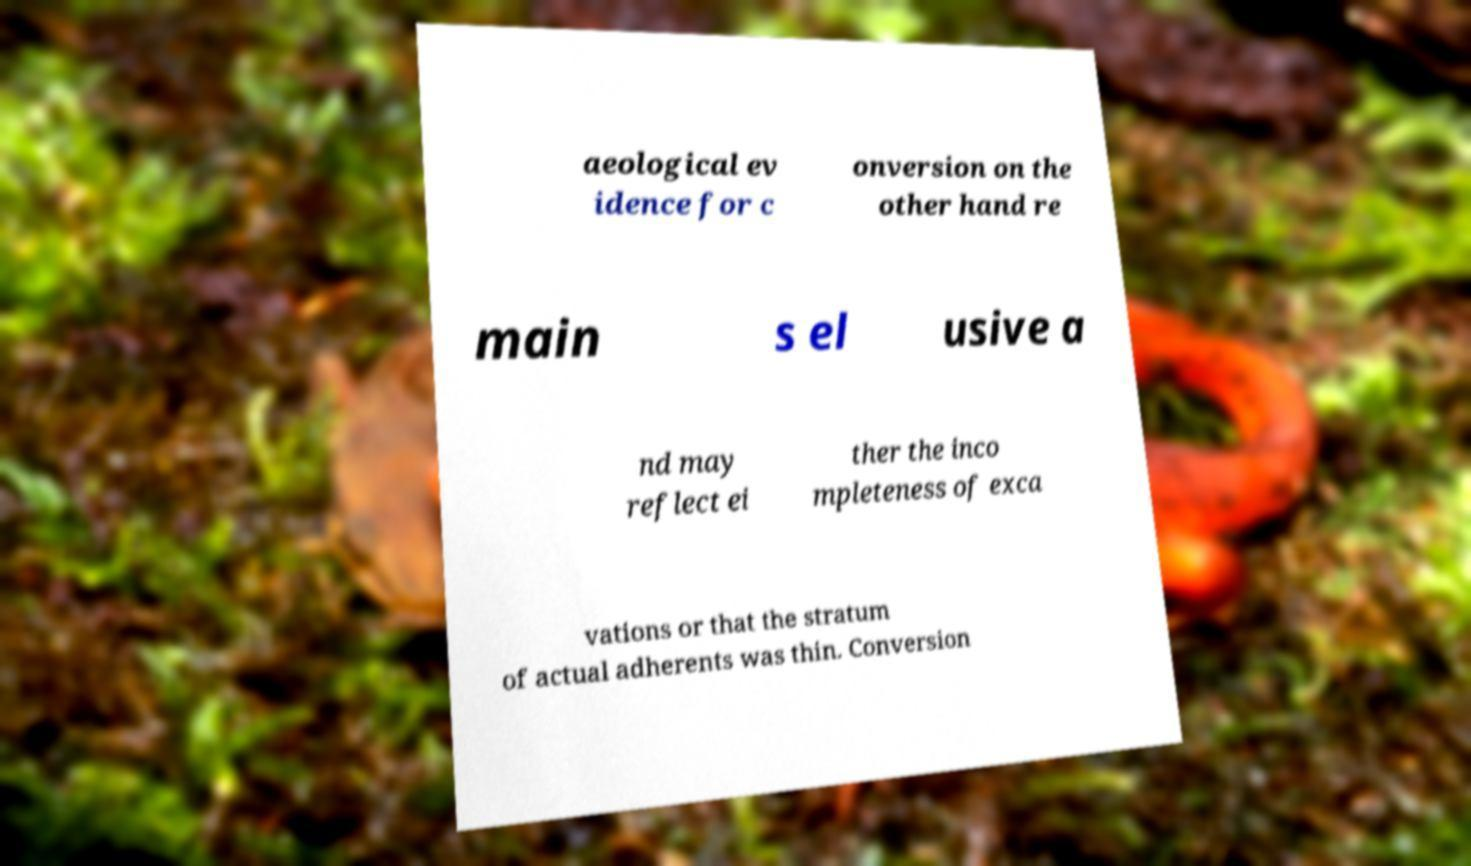Can you read and provide the text displayed in the image?This photo seems to have some interesting text. Can you extract and type it out for me? aeological ev idence for c onversion on the other hand re main s el usive a nd may reflect ei ther the inco mpleteness of exca vations or that the stratum of actual adherents was thin. Conversion 